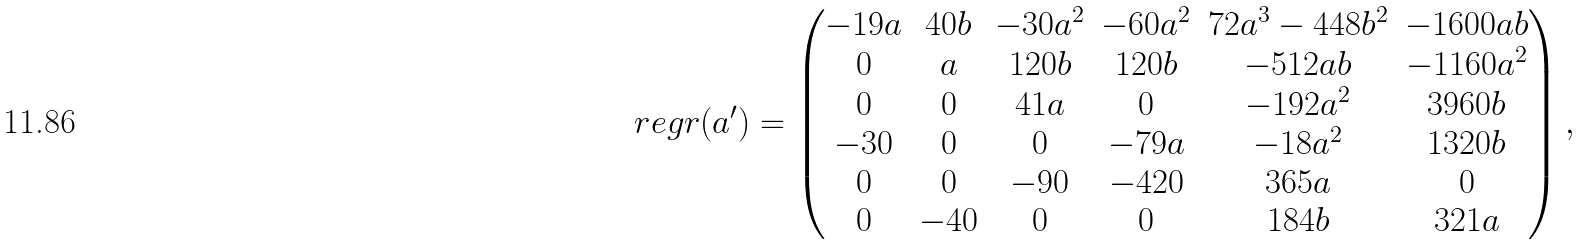Convert formula to latex. <formula><loc_0><loc_0><loc_500><loc_500>\ r e g r ( a ^ { \prime } ) = \begin{pmatrix} - 1 9 a & 4 0 b & - 3 0 a ^ { 2 } & - 6 0 a ^ { 2 } & 7 2 a ^ { 3 } - 4 4 8 b ^ { 2 } & - 1 6 0 0 a b \\ 0 & a & 1 2 0 b & 1 2 0 b & - 5 1 2 a b & - 1 1 6 0 a ^ { 2 } \\ 0 & 0 & 4 1 a & 0 & - 1 9 2 a ^ { 2 } & 3 9 6 0 b \\ - 3 0 & 0 & 0 & - 7 9 a & - 1 8 a ^ { 2 } & 1 3 2 0 b \\ 0 & 0 & - 9 0 & - 4 2 0 & 3 6 5 a & 0 \\ 0 & - 4 0 & 0 & 0 & 1 8 4 b & 3 2 1 a \end{pmatrix} ,</formula> 